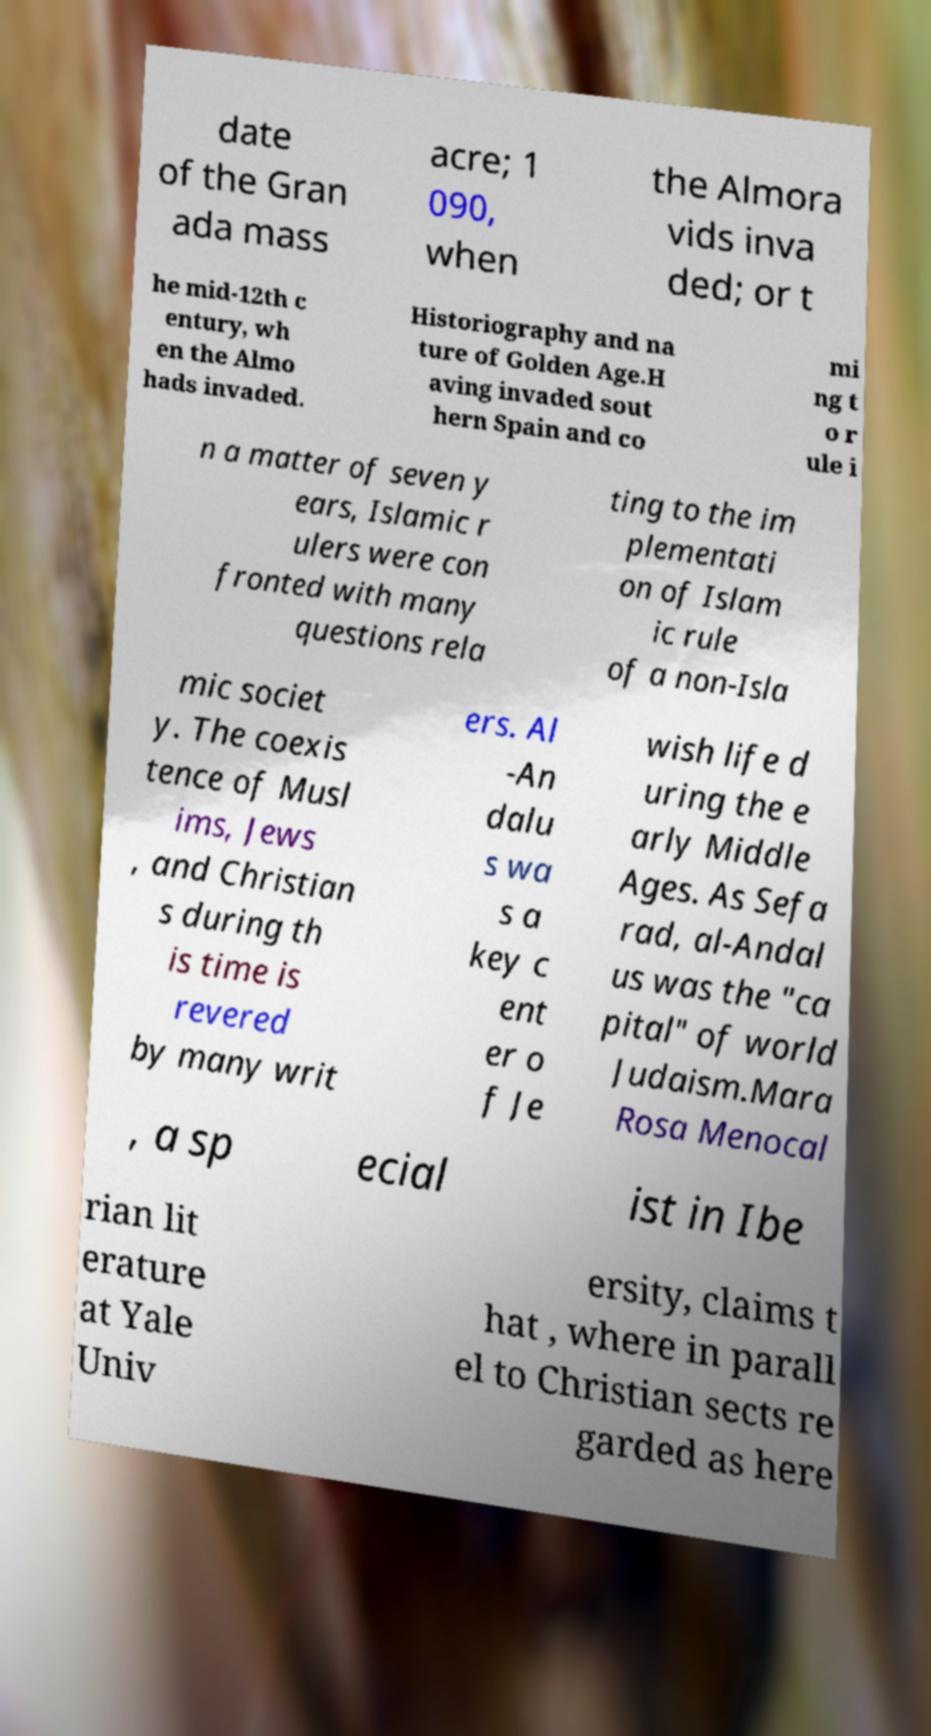Please identify and transcribe the text found in this image. date of the Gran ada mass acre; 1 090, when the Almora vids inva ded; or t he mid-12th c entury, wh en the Almo hads invaded. Historiography and na ture of Golden Age.H aving invaded sout hern Spain and co mi ng t o r ule i n a matter of seven y ears, Islamic r ulers were con fronted with many questions rela ting to the im plementati on of Islam ic rule of a non-Isla mic societ y. The coexis tence of Musl ims, Jews , and Christian s during th is time is revered by many writ ers. Al -An dalu s wa s a key c ent er o f Je wish life d uring the e arly Middle Ages. As Sefa rad, al-Andal us was the "ca pital" of world Judaism.Mara Rosa Menocal , a sp ecial ist in Ibe rian lit erature at Yale Univ ersity, claims t hat , where in parall el to Christian sects re garded as here 